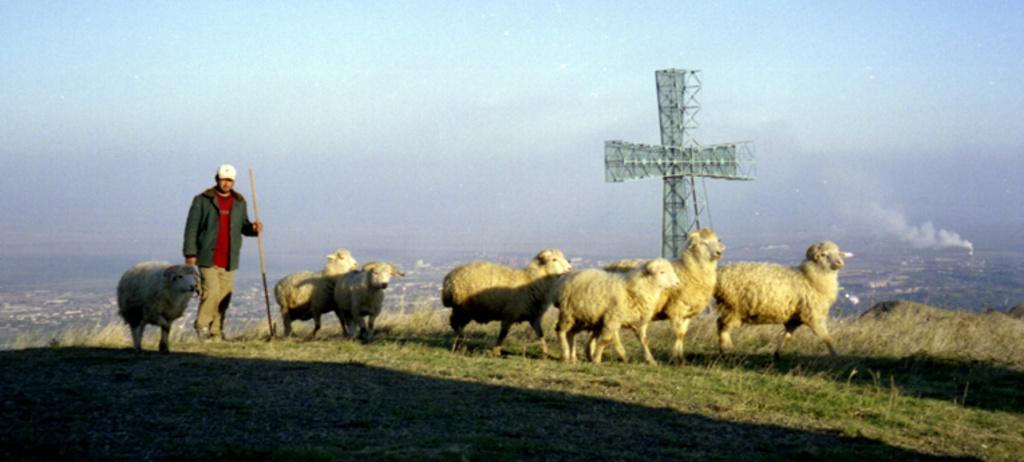Describe this image in one or two sentences. In this image we can see a few sheep on the grass, a person holding a stick and a tower and sky in the background. 